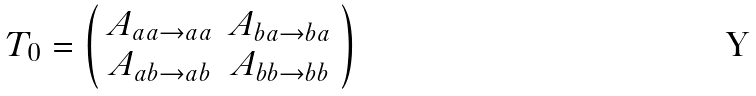<formula> <loc_0><loc_0><loc_500><loc_500>T _ { 0 } = \left ( \begin{array} { c c } A _ { a a \rightarrow a a } & A _ { b a \rightarrow b a } \\ A _ { a b \rightarrow a b } & A _ { b b \rightarrow b b } \end{array} \right )</formula> 